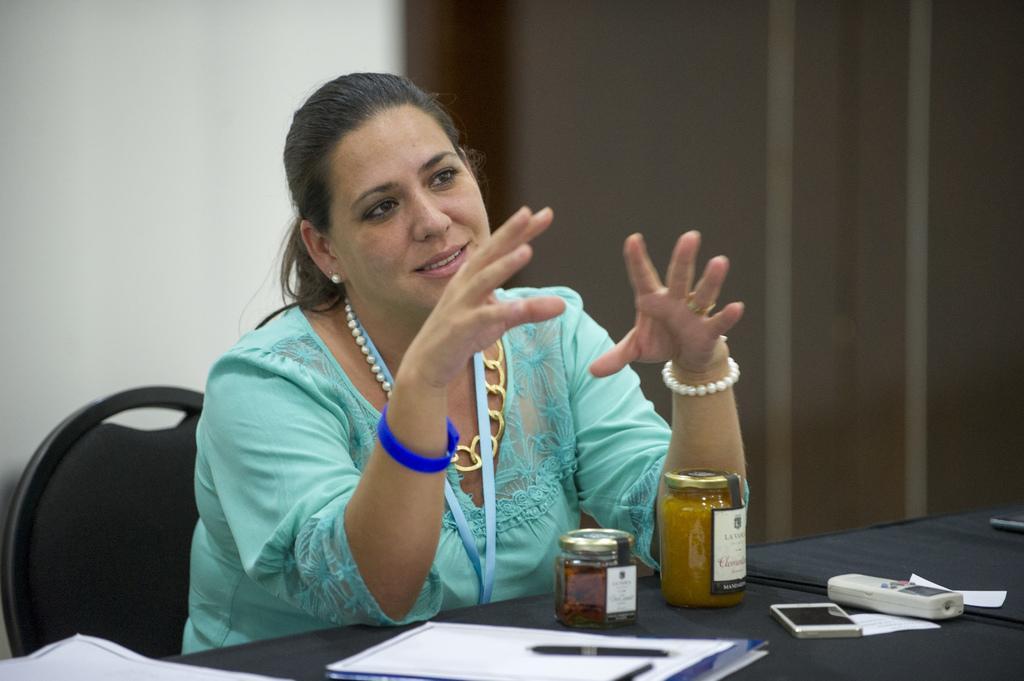Please provide a concise description of this image. In this image there is a woman sitting in the chair by keeping her hands on the table. On the table there are two jars,papers,pens,mobile phone and a remote. In the background there is a wall. 